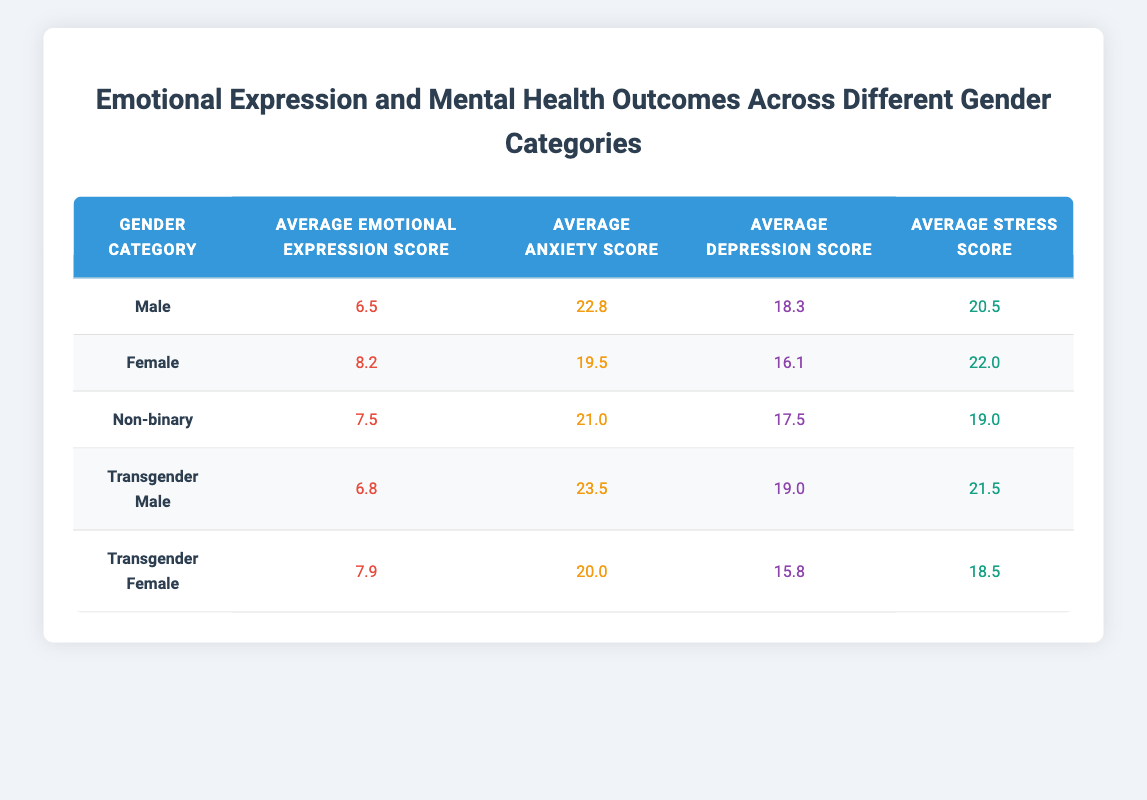What is the average emotional expression score for males? The table indicates that the average emotional expression score for males is listed directly in the corresponding row under the "Average Emotional Expression Score" column. The value given is 6.5.
Answer: 6.5 What is the average anxiety score for transgender females? Males are listed under the "Transgender Female" category, and their average anxiety score is directly noted as 20.0 in the table under the "Average Anxiety Score."
Answer: 20.0 What is the average depression score for non-binary individuals? By referring to the row designated for non-binary individuals, the average depression score is found in the "Average Depression Score" column, which indicates a value of 17.5.
Answer: 17.5 What is the difference in average emotional expression scores between females and transgender males? The average emotional expression score for females is 8.2, and for transgender males, it is 6.8. To find the difference, subtract 6.8 from 8.2: 8.2 - 6.8 = 1.4.
Answer: 1.4 Is the average anxiety score for males higher than that of females? The average anxiety score for males is 22.8, while for females, it is 19.5. Since 22.8 is greater than 19.5, the statement is true.
Answer: Yes What is the average stress score for all gender categories? To find the average stress score, add all the stress scores: 20.5 (male) + 22.0 (female) + 19.0 (non-binary) + 21.5 (transgender male) + 18.5 (transgender female) = 101.0. Then, divide this sum by the number of categories, which is 5: 101.0 / 5 = 20.2.
Answer: 20.2 Which gender category has the lowest average depression score? Searching through the "Average Depression Score" column, the scores for each category are: male (18.3), female (16.1), non-binary (17.5), transgender male (19.0), and transgender female (15.8). The lowest score is 15.8, corresponding to transgender females.
Answer: Transgender Female 